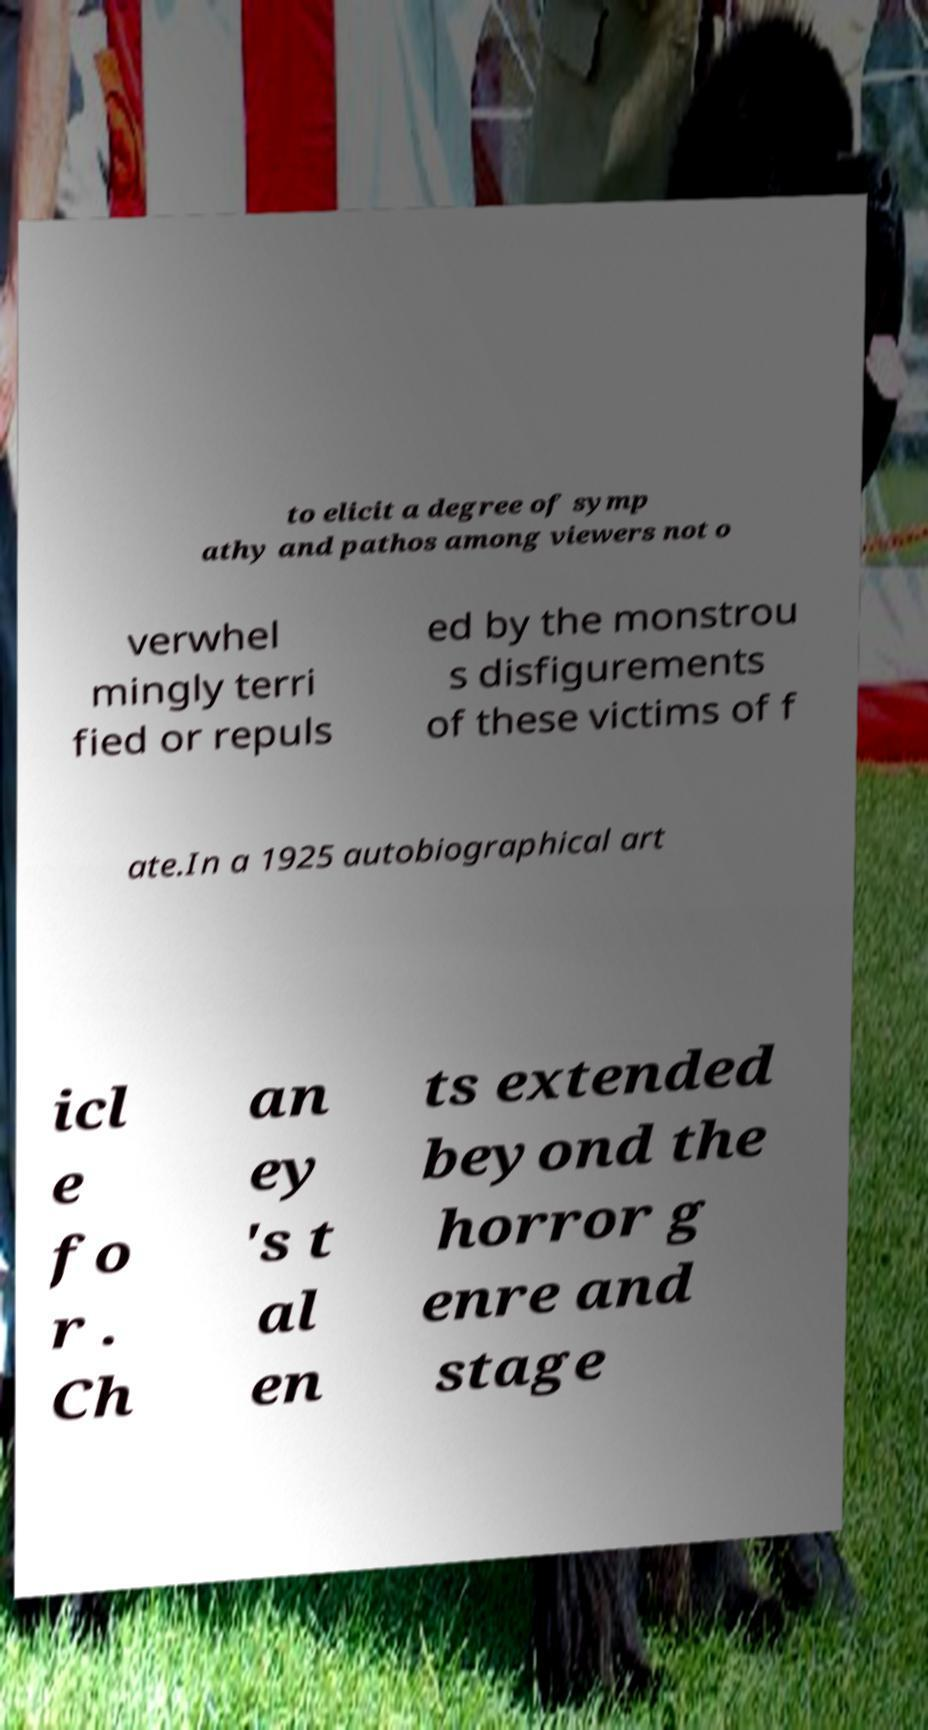Could you extract and type out the text from this image? to elicit a degree of symp athy and pathos among viewers not o verwhel mingly terri fied or repuls ed by the monstrou s disfigurements of these victims of f ate.In a 1925 autobiographical art icl e fo r . Ch an ey 's t al en ts extended beyond the horror g enre and stage 